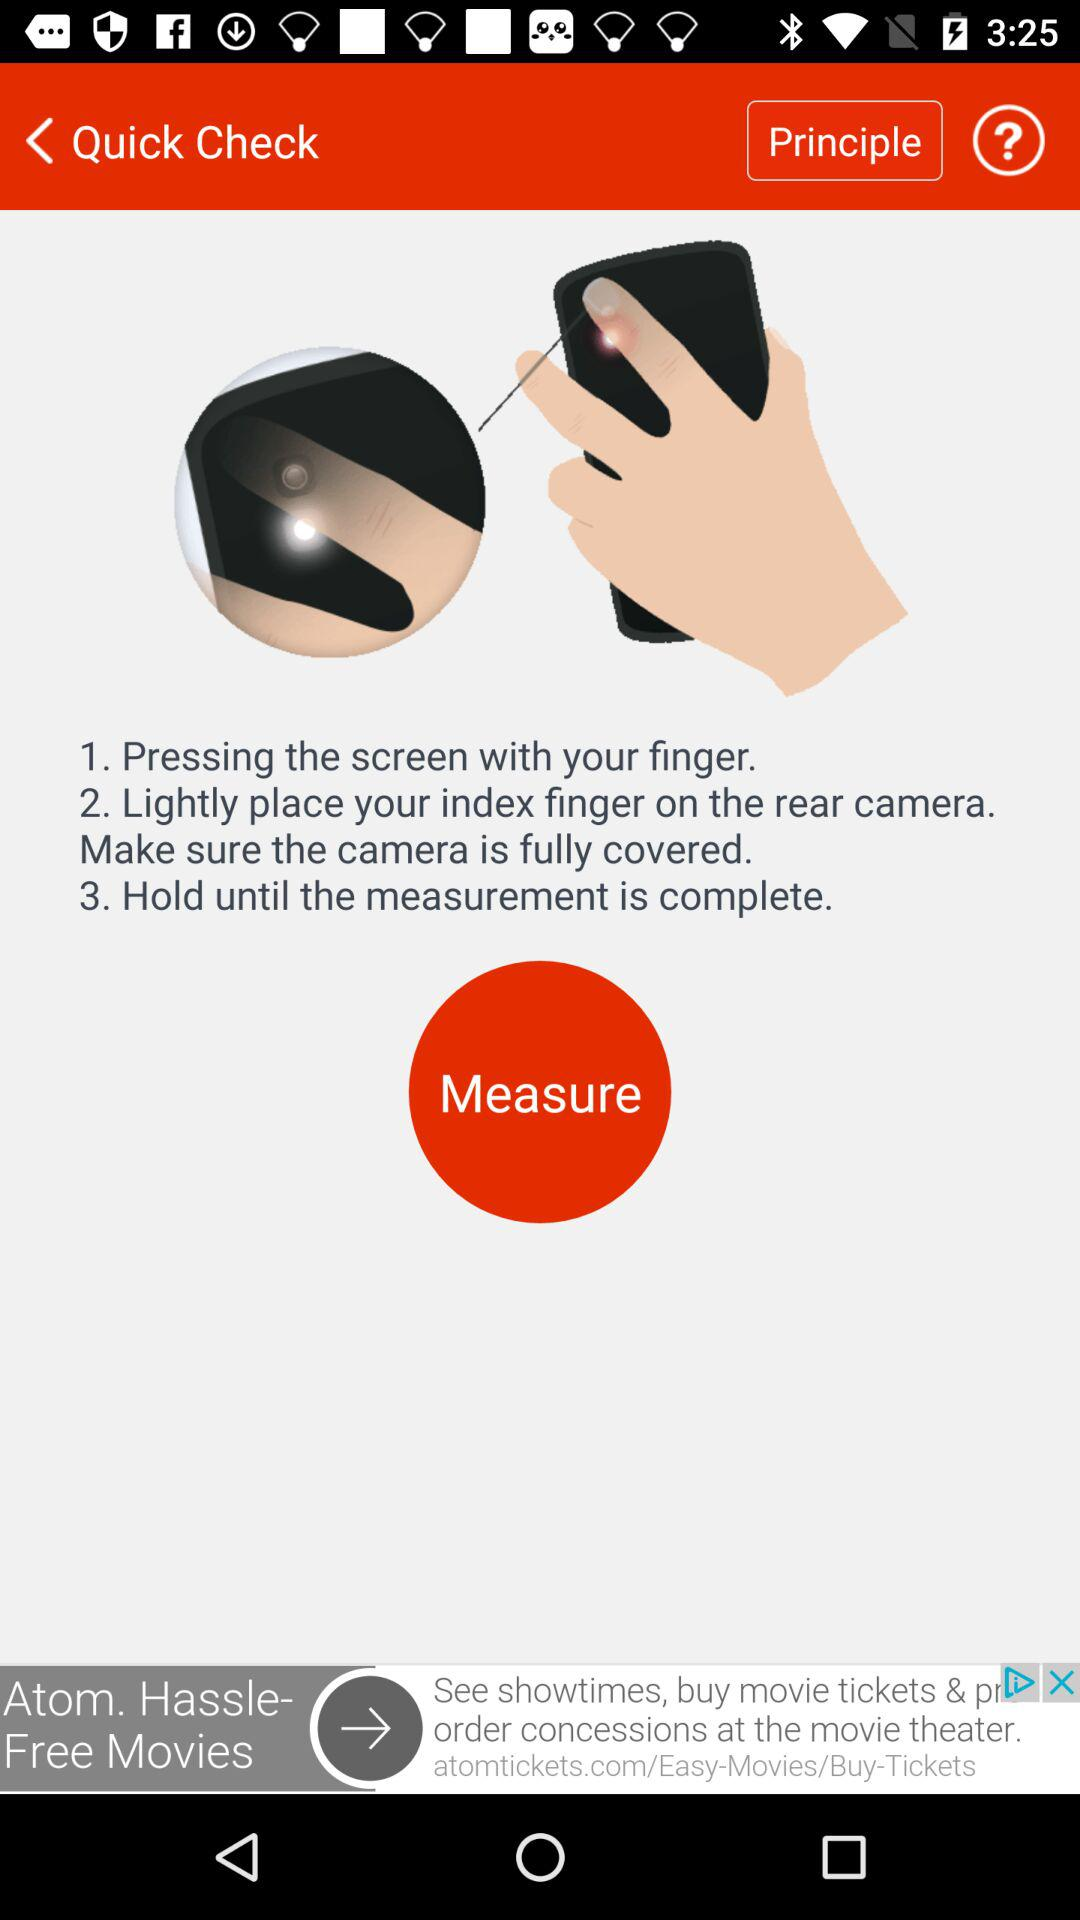How many steps are there in the process?
Answer the question using a single word or phrase. 3 